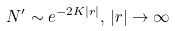<formula> <loc_0><loc_0><loc_500><loc_500>N ^ { \prime } \sim e ^ { - 2 K | r | } , \, | r | \rightarrow \infty</formula> 